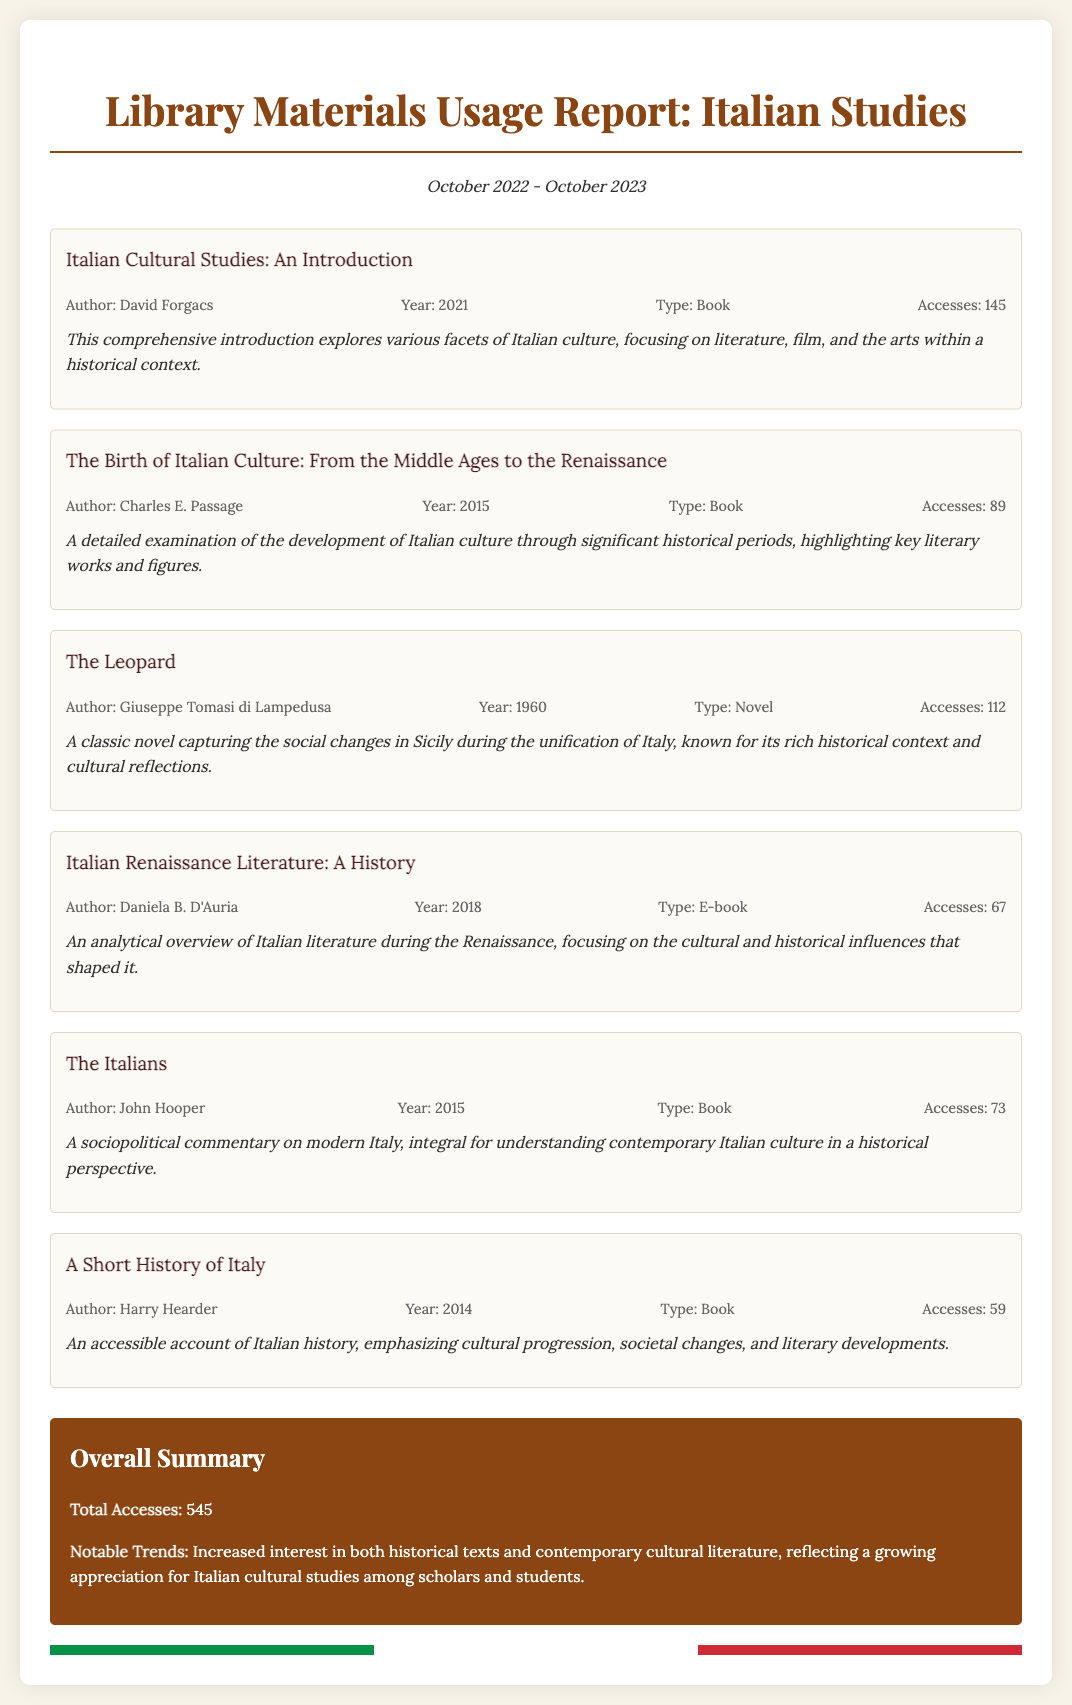What is the title of the most accessed resource? The most accessed resource is determined by the number of accesses listed; "Italian Cultural Studies: An Introduction" has the highest at 145 accesses.
Answer: Italian Cultural Studies: An Introduction How many accesses did "The Leopard" receive? The number of accesses for "The Leopard" is directly stated in the resource information; it received 112 accesses.
Answer: 112 Who is the author of "A Short History of Italy"? The author of "A Short History of Italy" is mentioned in its resource information; it is Harry Hearder.
Answer: Harry Hearder What year was "The Birth of Italian Culture: From the Middle Ages to the Renaissance" published? The publication year is provided in the resource details of the book; it was published in 2015.
Answer: 2015 What is the total number of accesses for all resources combined? The total number of accesses is summarized at the end of the document; it totals 545 accesses.
Answer: 545 Identify one notable trend in library material usage. A notable trend is indicated in the overall summary section, reflecting a growing appreciation for historical texts and contemporary literature.
Answer: Increased interest in historical texts and contemporary cultural literature How many e-books were accessed in the past year? The document lists only one e-book ("Italian Renaissance Literature: A History"), and its access count is provided as 67.
Answer: 67 What type of literature does "Italian Renaissance Literature: A History" focus on? The type of literature is specified in its summary; it focuses on Italian literature during the Renaissance.
Answer: Italian literature during the Renaissance How many total resources are mentioned in the report? The number of resources can be counted from the document where six resources are listed.
Answer: 6 